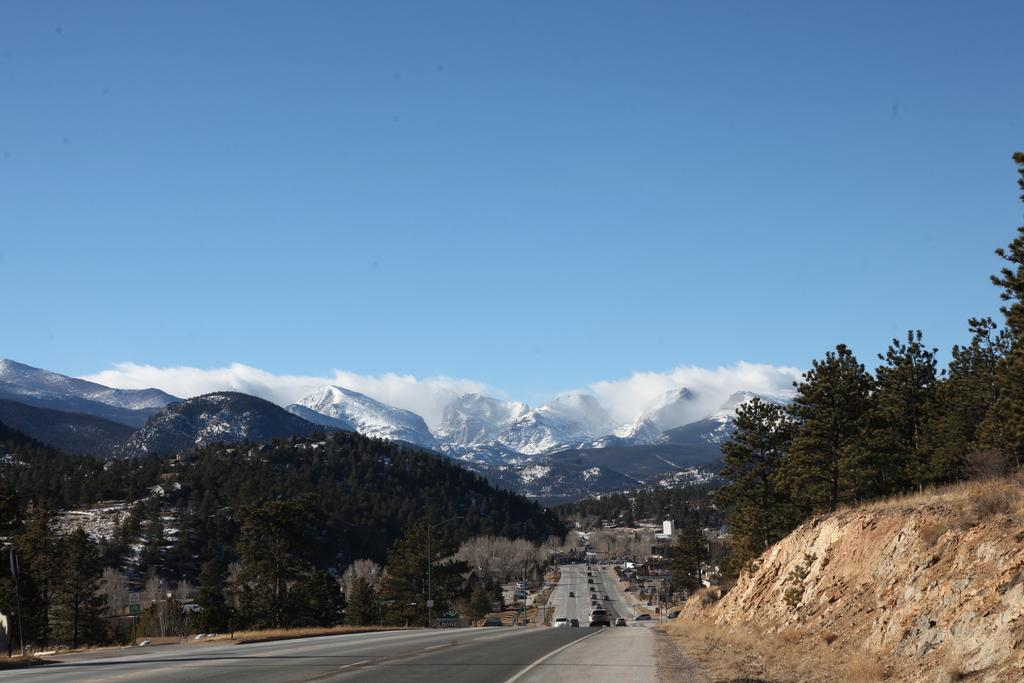What is the main subject of the image? The main subject of the image is a group of vehicles parked on the road. What can be seen in the background of the image? In the background, there is a group of trees, poles, mountains, and a cloudy sky. How many vehicles are parked on the road? The number of vehicles is not specified in the facts, so we cannot determine the exact number. What type of teeth can be seen on the ducks in the image? There are no ducks present in the image, so there are no teeth to observe. 